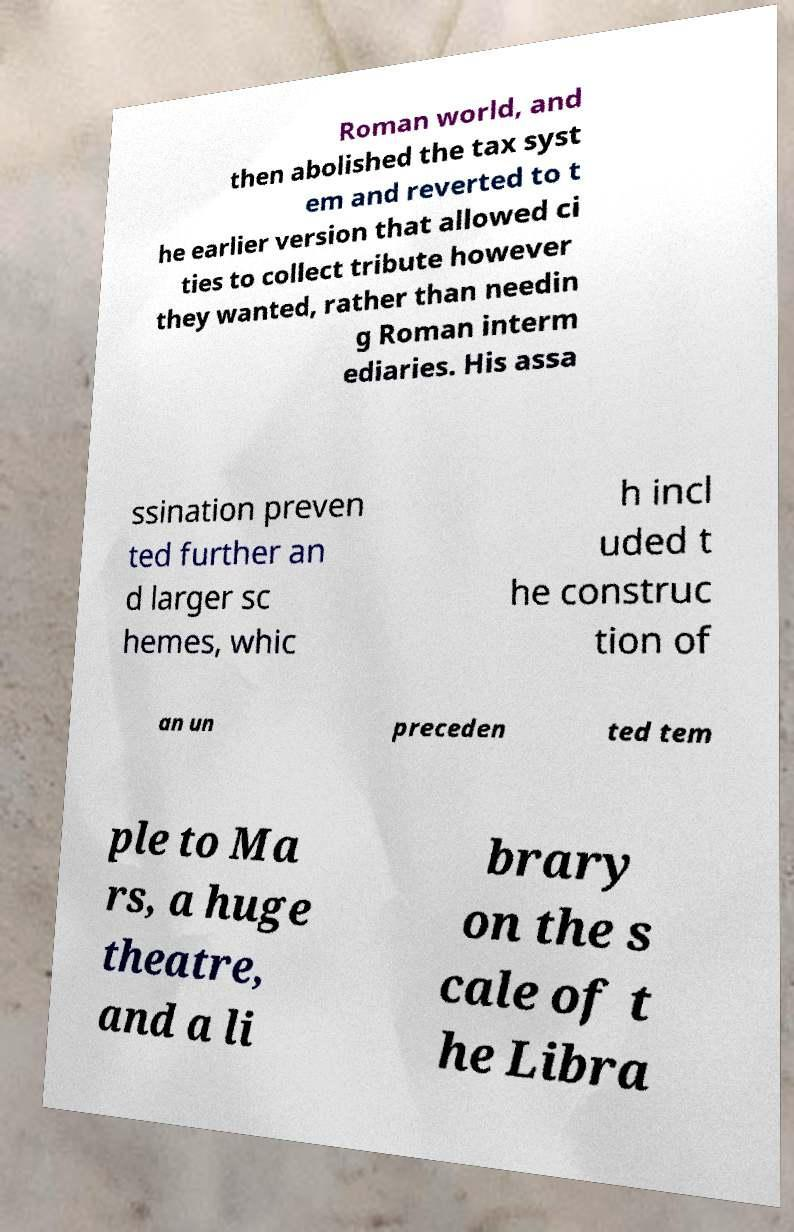Can you read and provide the text displayed in the image?This photo seems to have some interesting text. Can you extract and type it out for me? Roman world, and then abolished the tax syst em and reverted to t he earlier version that allowed ci ties to collect tribute however they wanted, rather than needin g Roman interm ediaries. His assa ssination preven ted further an d larger sc hemes, whic h incl uded t he construc tion of an un preceden ted tem ple to Ma rs, a huge theatre, and a li brary on the s cale of t he Libra 